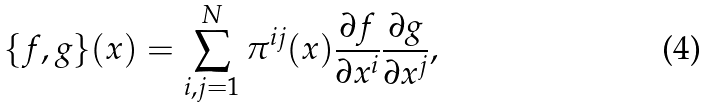Convert formula to latex. <formula><loc_0><loc_0><loc_500><loc_500>\{ f , g \} ( { x } ) = \sum _ { i , j = 1 } ^ { N } \pi ^ { i j } ( { x } ) \frac { \partial f } { \partial x ^ { i } } \frac { \partial g } { \partial x ^ { j } } ,</formula> 